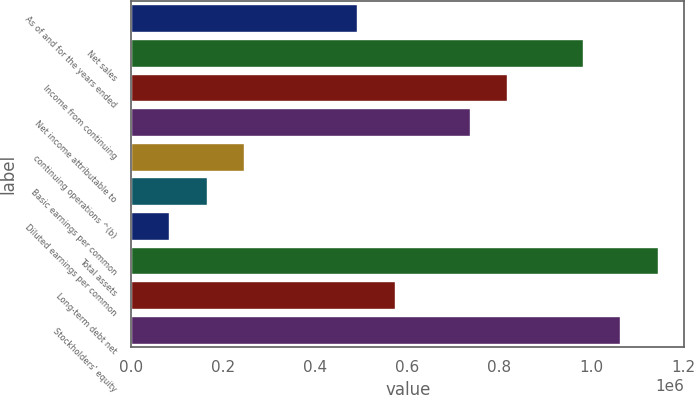Convert chart to OTSL. <chart><loc_0><loc_0><loc_500><loc_500><bar_chart><fcel>As of and for the years ended<fcel>Net sales<fcel>Income from continuing<fcel>Net income attributable to<fcel>continuing operations ^(b)<fcel>Basic earnings per common<fcel>Diluted earnings per common<fcel>Total assets<fcel>Long-term debt net<fcel>Stockholders' equity<nl><fcel>490581<fcel>981162<fcel>817635<fcel>735872<fcel>245291<fcel>163528<fcel>81764.6<fcel>1.14469e+06<fcel>572345<fcel>1.06293e+06<nl></chart> 